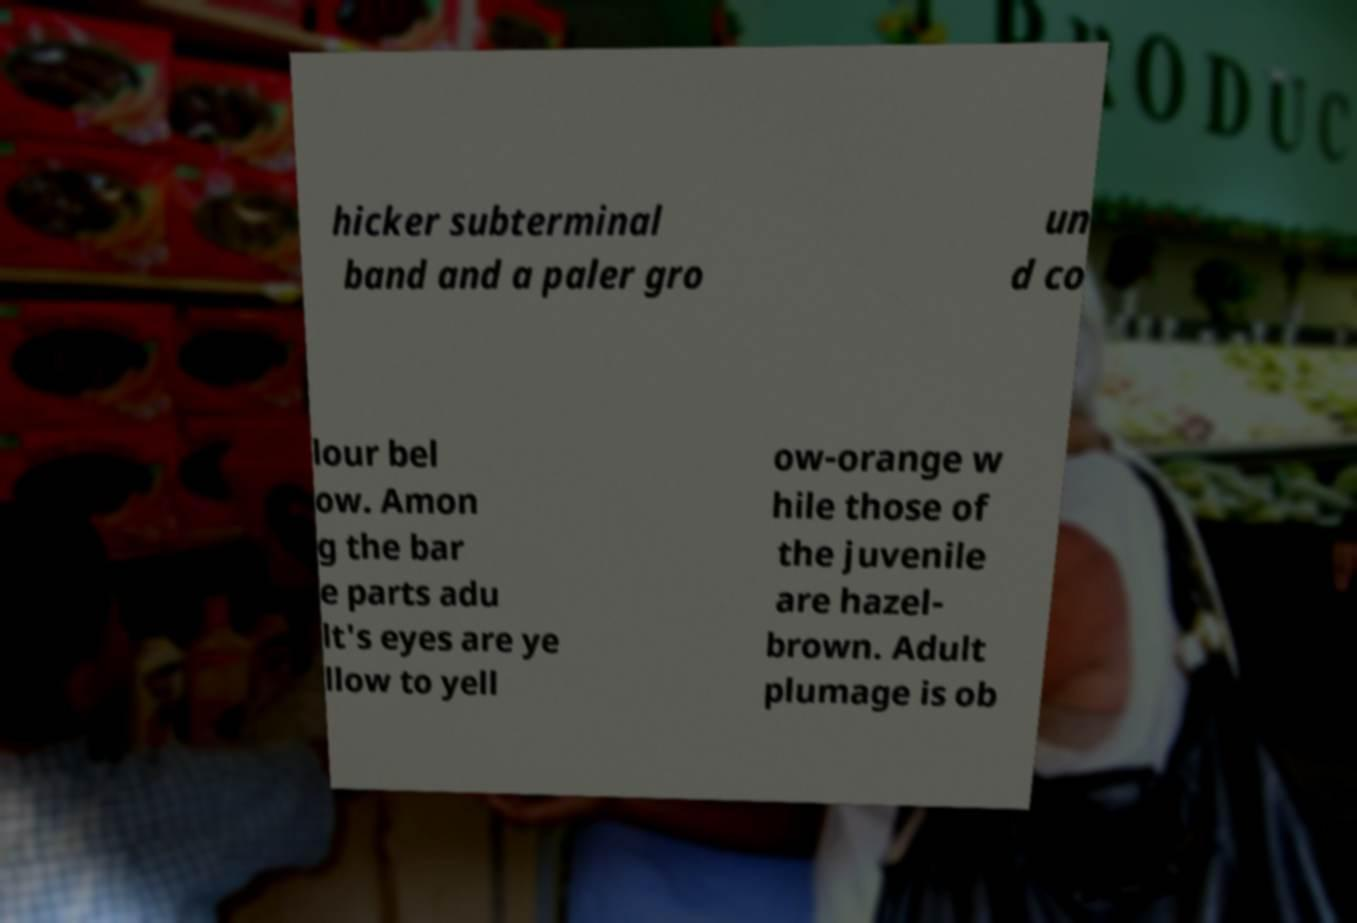What messages or text are displayed in this image? I need them in a readable, typed format. hicker subterminal band and a paler gro un d co lour bel ow. Amon g the bar e parts adu lt's eyes are ye llow to yell ow-orange w hile those of the juvenile are hazel- brown. Adult plumage is ob 